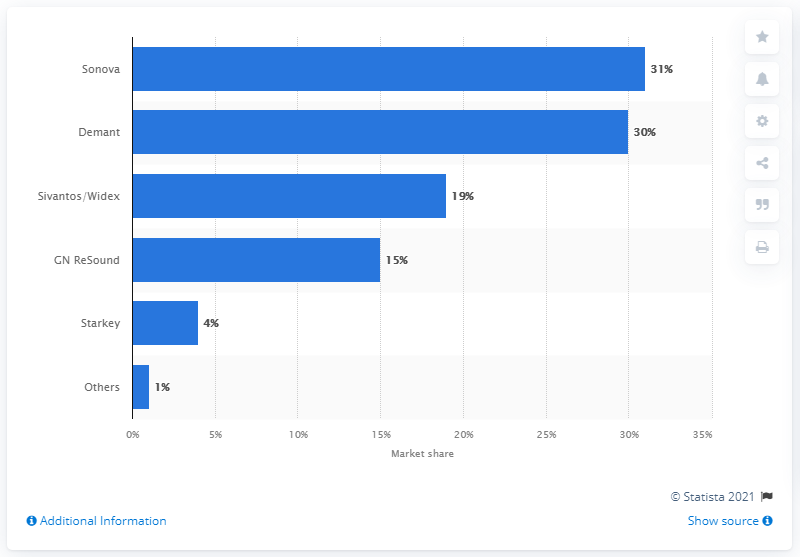Point out several critical features in this image. Sonova had the largest share of the global hearing aid market. 